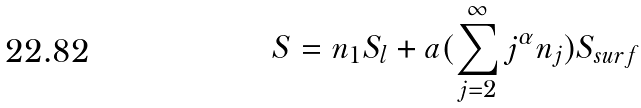Convert formula to latex. <formula><loc_0><loc_0><loc_500><loc_500>S = n _ { 1 } S _ { l } + a ( \sum _ { j = 2 } ^ { \infty } j ^ { \alpha } n _ { j } ) S _ { s u r f }</formula> 